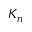Convert formula to latex. <formula><loc_0><loc_0><loc_500><loc_500>K _ { n }</formula> 